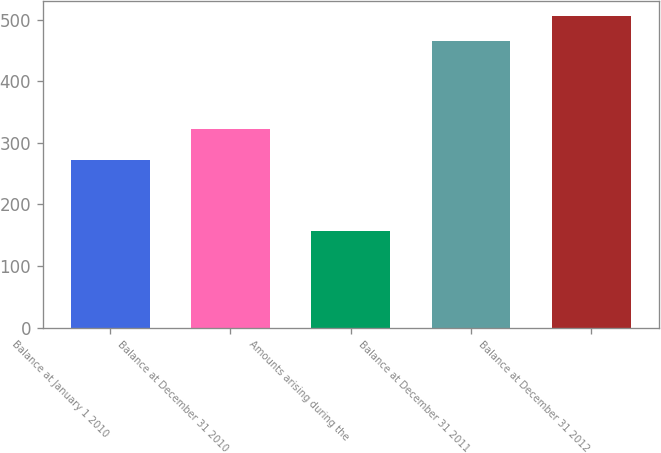Convert chart. <chart><loc_0><loc_0><loc_500><loc_500><bar_chart><fcel>Balance at January 1 2010<fcel>Balance at December 31 2010<fcel>Amounts arising during the<fcel>Balance at December 31 2011<fcel>Balance at December 31 2012<nl><fcel>273<fcel>323<fcel>157<fcel>465<fcel>506<nl></chart> 